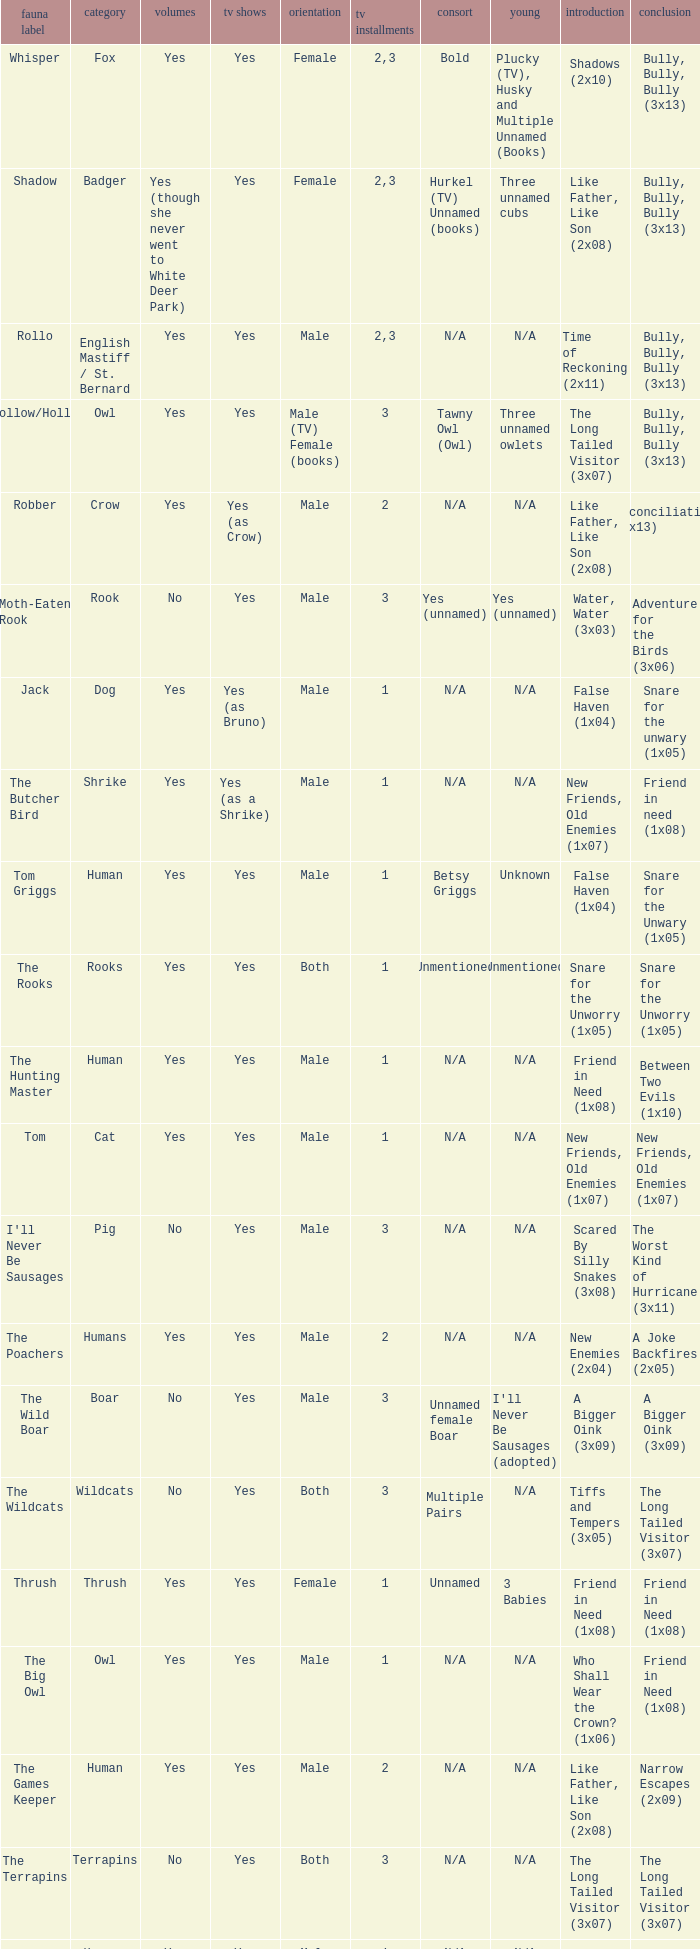What is the mate for Last Appearance of bully, bully, bully (3x13) for the animal named hollow/holly later than season 1? Tawny Owl (Owl). 